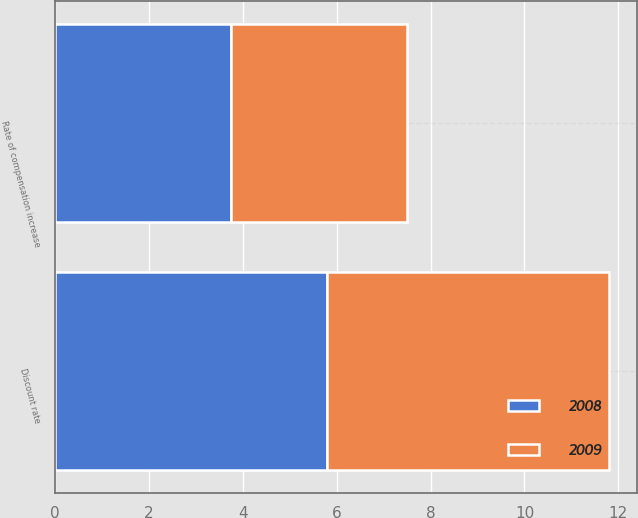<chart> <loc_0><loc_0><loc_500><loc_500><stacked_bar_chart><ecel><fcel>Discount rate<fcel>Rate of compensation increase<nl><fcel>2008<fcel>5.8<fcel>3.75<nl><fcel>2009<fcel>6<fcel>3.75<nl></chart> 